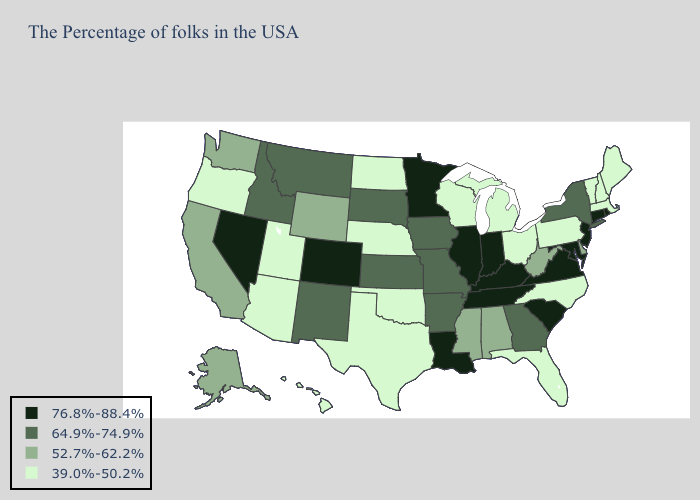What is the value of Iowa?
Be succinct. 64.9%-74.9%. What is the highest value in the USA?
Short answer required. 76.8%-88.4%. Which states hav the highest value in the Northeast?
Give a very brief answer. Rhode Island, Connecticut, New Jersey. Does Louisiana have the same value as Colorado?
Short answer required. Yes. What is the value of Oregon?
Write a very short answer. 39.0%-50.2%. Which states have the lowest value in the USA?
Short answer required. Maine, Massachusetts, New Hampshire, Vermont, Pennsylvania, North Carolina, Ohio, Florida, Michigan, Wisconsin, Nebraska, Oklahoma, Texas, North Dakota, Utah, Arizona, Oregon, Hawaii. Among the states that border Alabama , which have the highest value?
Be succinct. Tennessee. Name the states that have a value in the range 39.0%-50.2%?
Keep it brief. Maine, Massachusetts, New Hampshire, Vermont, Pennsylvania, North Carolina, Ohio, Florida, Michigan, Wisconsin, Nebraska, Oklahoma, Texas, North Dakota, Utah, Arizona, Oregon, Hawaii. What is the value of Nevada?
Keep it brief. 76.8%-88.4%. Does Rhode Island have the lowest value in the USA?
Short answer required. No. Name the states that have a value in the range 76.8%-88.4%?
Quick response, please. Rhode Island, Connecticut, New Jersey, Maryland, Virginia, South Carolina, Kentucky, Indiana, Tennessee, Illinois, Louisiana, Minnesota, Colorado, Nevada. What is the value of Kansas?
Answer briefly. 64.9%-74.9%. 